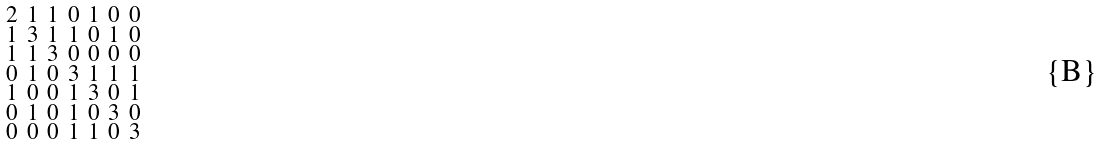Convert formula to latex. <formula><loc_0><loc_0><loc_500><loc_500>\begin{smallmatrix} 2 & 1 & 1 & 0 & 1 & 0 & 0 \\ 1 & 3 & 1 & 1 & 0 & 1 & 0 \\ 1 & 1 & 3 & 0 & 0 & 0 & 0 \\ 0 & 1 & 0 & 3 & 1 & 1 & 1 \\ 1 & 0 & 0 & 1 & 3 & 0 & 1 \\ 0 & 1 & 0 & 1 & 0 & 3 & 0 \\ 0 & 0 & 0 & 1 & 1 & 0 & 3 \end{smallmatrix}</formula> 